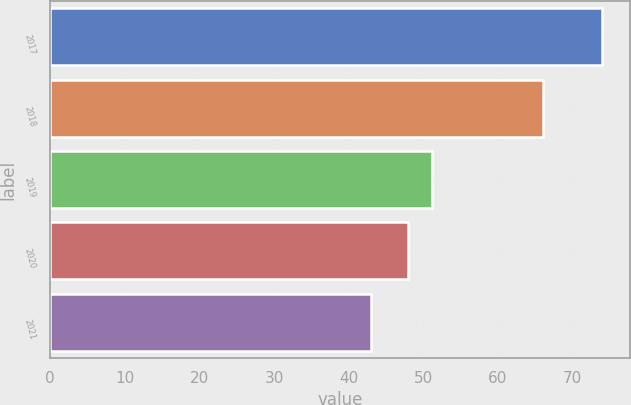Convert chart. <chart><loc_0><loc_0><loc_500><loc_500><bar_chart><fcel>2017<fcel>2018<fcel>2019<fcel>2020<fcel>2021<nl><fcel>74<fcel>66<fcel>51.1<fcel>48<fcel>43<nl></chart> 